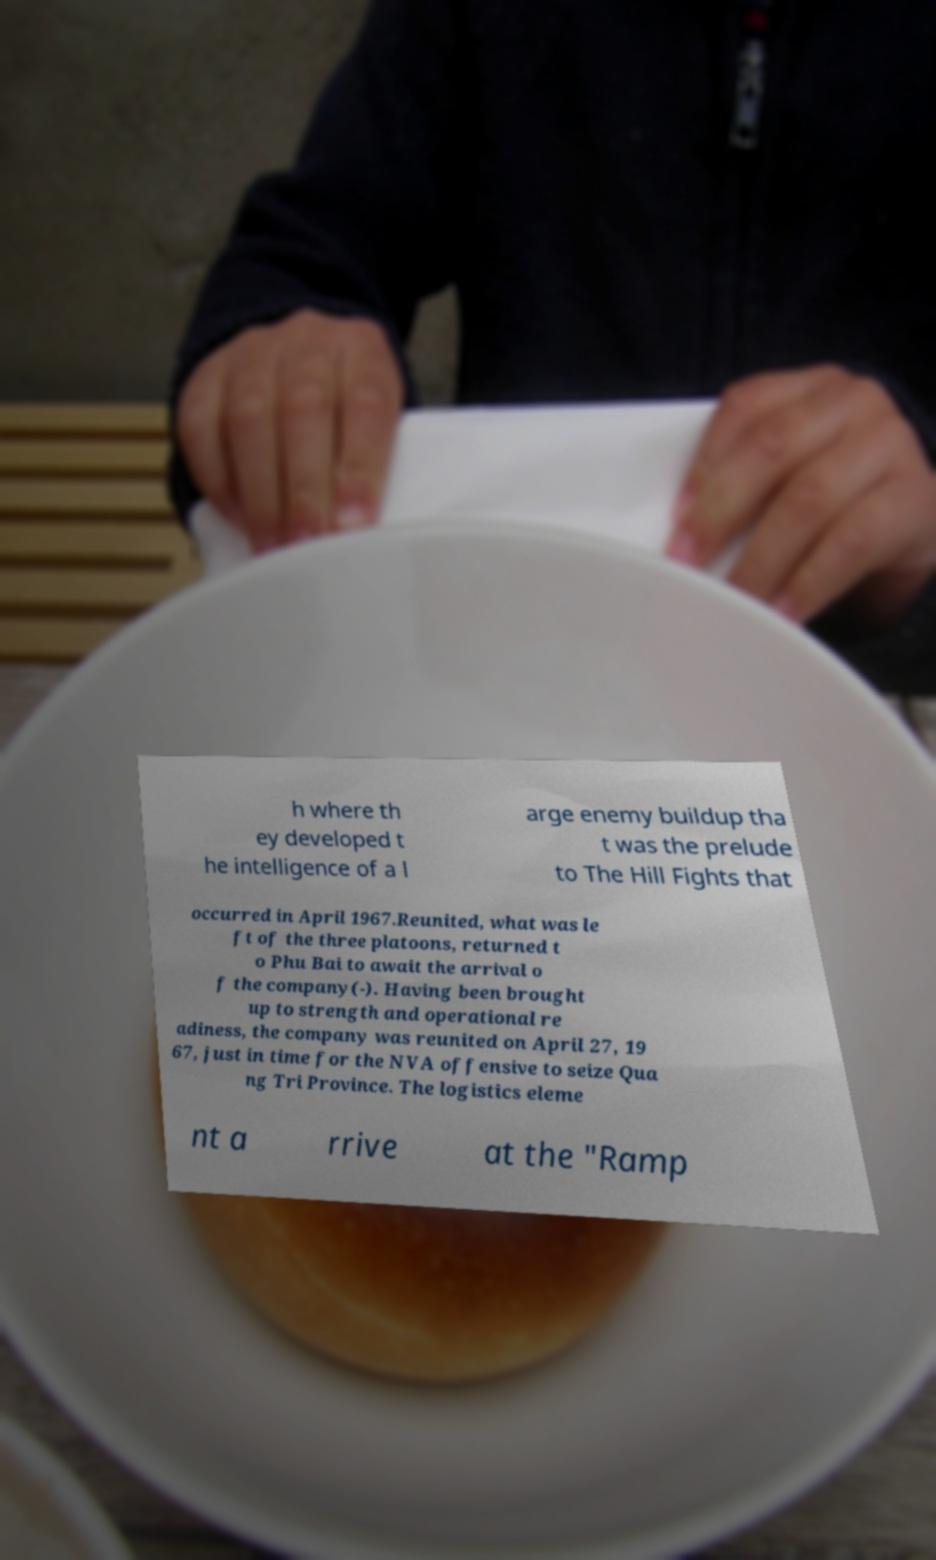Could you assist in decoding the text presented in this image and type it out clearly? h where th ey developed t he intelligence of a l arge enemy buildup tha t was the prelude to The Hill Fights that occurred in April 1967.Reunited, what was le ft of the three platoons, returned t o Phu Bai to await the arrival o f the company(-). Having been brought up to strength and operational re adiness, the company was reunited on April 27, 19 67, just in time for the NVA offensive to seize Qua ng Tri Province. The logistics eleme nt a rrive at the "Ramp 